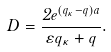<formula> <loc_0><loc_0><loc_500><loc_500>D = \frac { 2 e ^ { ( q _ { \kappa } - q ) a } } { \varepsilon q _ { \kappa } + q } .</formula> 